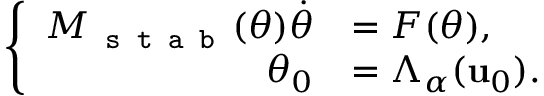Convert formula to latex. <formula><loc_0><loc_0><loc_500><loc_500>\left \{ \begin{array} { r l } { M _ { s t a b } ( \theta ) \dot { \theta } } & { = F ( \theta ) , } \\ { \theta _ { 0 } } & { = \Lambda _ { \alpha } ( u _ { 0 } ) . } \end{array}</formula> 